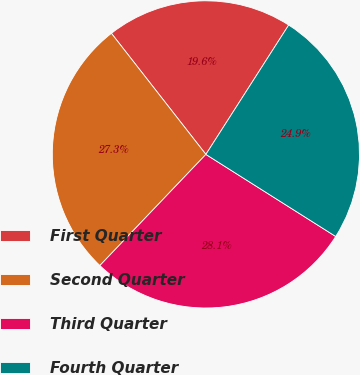<chart> <loc_0><loc_0><loc_500><loc_500><pie_chart><fcel>First Quarter<fcel>Second Quarter<fcel>Third Quarter<fcel>Fourth Quarter<nl><fcel>19.61%<fcel>27.33%<fcel>28.15%<fcel>24.91%<nl></chart> 